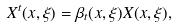<formula> <loc_0><loc_0><loc_500><loc_500>X ^ { t } ( x , \xi ) = \beta _ { t } ( x , \xi ) X ( x , \xi ) ,</formula> 